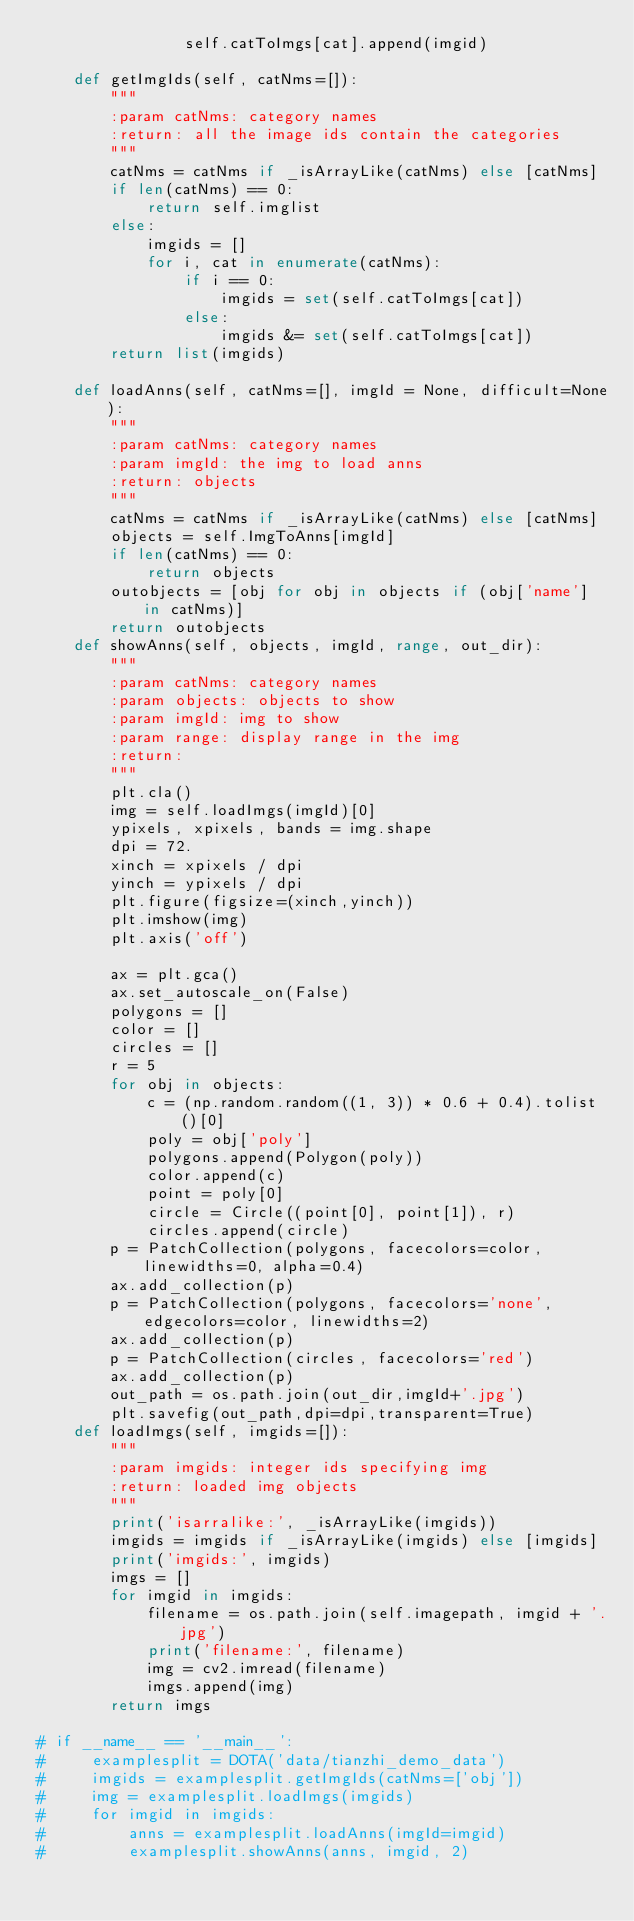Convert code to text. <code><loc_0><loc_0><loc_500><loc_500><_Python_>                self.catToImgs[cat].append(imgid)

    def getImgIds(self, catNms=[]):
        """
        :param catNms: category names
        :return: all the image ids contain the categories
        """
        catNms = catNms if _isArrayLike(catNms) else [catNms]
        if len(catNms) == 0:
            return self.imglist
        else:
            imgids = []
            for i, cat in enumerate(catNms):
                if i == 0:
                    imgids = set(self.catToImgs[cat])
                else:
                    imgids &= set(self.catToImgs[cat])
        return list(imgids)

    def loadAnns(self, catNms=[], imgId = None, difficult=None):
        """
        :param catNms: category names
        :param imgId: the img to load anns
        :return: objects
        """
        catNms = catNms if _isArrayLike(catNms) else [catNms]
        objects = self.ImgToAnns[imgId]
        if len(catNms) == 0:
            return objects
        outobjects = [obj for obj in objects if (obj['name'] in catNms)]
        return outobjects
    def showAnns(self, objects, imgId, range, out_dir):
        """
        :param catNms: category names
        :param objects: objects to show
        :param imgId: img to show
        :param range: display range in the img
        :return:
        """
        plt.cla()
        img = self.loadImgs(imgId)[0]
        ypixels, xpixels, bands = img.shape
        dpi = 72.
        xinch = xpixels / dpi
        yinch = ypixels / dpi
        plt.figure(figsize=(xinch,yinch))
        plt.imshow(img)
        plt.axis('off')

        ax = plt.gca()
        ax.set_autoscale_on(False)
        polygons = []
        color = []
        circles = []
        r = 5
        for obj in objects:
            c = (np.random.random((1, 3)) * 0.6 + 0.4).tolist()[0]
            poly = obj['poly']
            polygons.append(Polygon(poly))
            color.append(c)
            point = poly[0]
            circle = Circle((point[0], point[1]), r)
            circles.append(circle)
        p = PatchCollection(polygons, facecolors=color, linewidths=0, alpha=0.4)
        ax.add_collection(p)
        p = PatchCollection(polygons, facecolors='none', edgecolors=color, linewidths=2)
        ax.add_collection(p)
        p = PatchCollection(circles, facecolors='red')
        ax.add_collection(p)
        out_path = os.path.join(out_dir,imgId+'.jpg')
        plt.savefig(out_path,dpi=dpi,transparent=True)
    def loadImgs(self, imgids=[]):
        """
        :param imgids: integer ids specifying img
        :return: loaded img objects
        """
        print('isarralike:', _isArrayLike(imgids))
        imgids = imgids if _isArrayLike(imgids) else [imgids]
        print('imgids:', imgids)
        imgs = []
        for imgid in imgids:
            filename = os.path.join(self.imagepath, imgid + '.jpg')
            print('filename:', filename)
            img = cv2.imread(filename)
            imgs.append(img)
        return imgs

# if __name__ == '__main__':
#     examplesplit = DOTA('data/tianzhi_demo_data')
#     imgids = examplesplit.getImgIds(catNms=['obj'])
#     img = examplesplit.loadImgs(imgids)
#     for imgid in imgids:
#         anns = examplesplit.loadAnns(imgId=imgid)
#         examplesplit.showAnns(anns, imgid, 2)</code> 